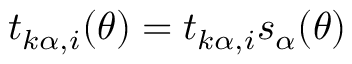Convert formula to latex. <formula><loc_0><loc_0><loc_500><loc_500>t _ { k \alpha , i } ( \theta ) = t _ { k \alpha , i } s _ { \alpha } ( \theta )</formula> 